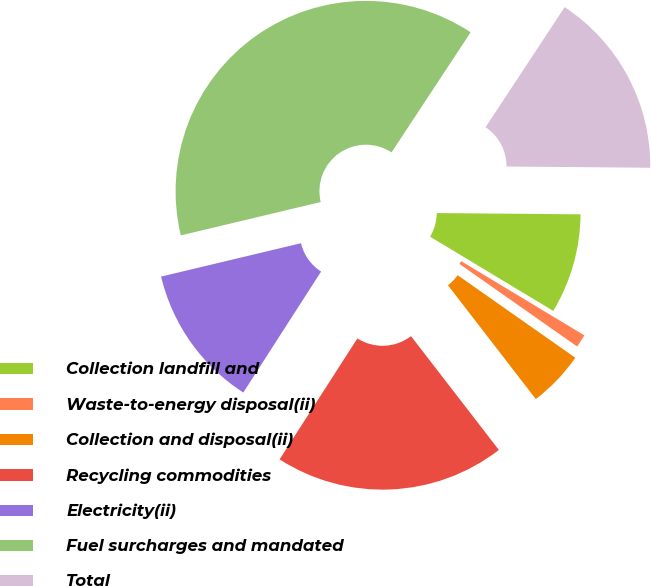Convert chart to OTSL. <chart><loc_0><loc_0><loc_500><loc_500><pie_chart><fcel>Collection landfill and<fcel>Waste-to-energy disposal(ii)<fcel>Collection and disposal(ii)<fcel>Recycling commodities<fcel>Electricity(ii)<fcel>Fuel surcharges and mandated<fcel>Total<nl><fcel>8.49%<fcel>1.11%<fcel>4.8%<fcel>19.56%<fcel>12.18%<fcel>38.0%<fcel>15.87%<nl></chart> 